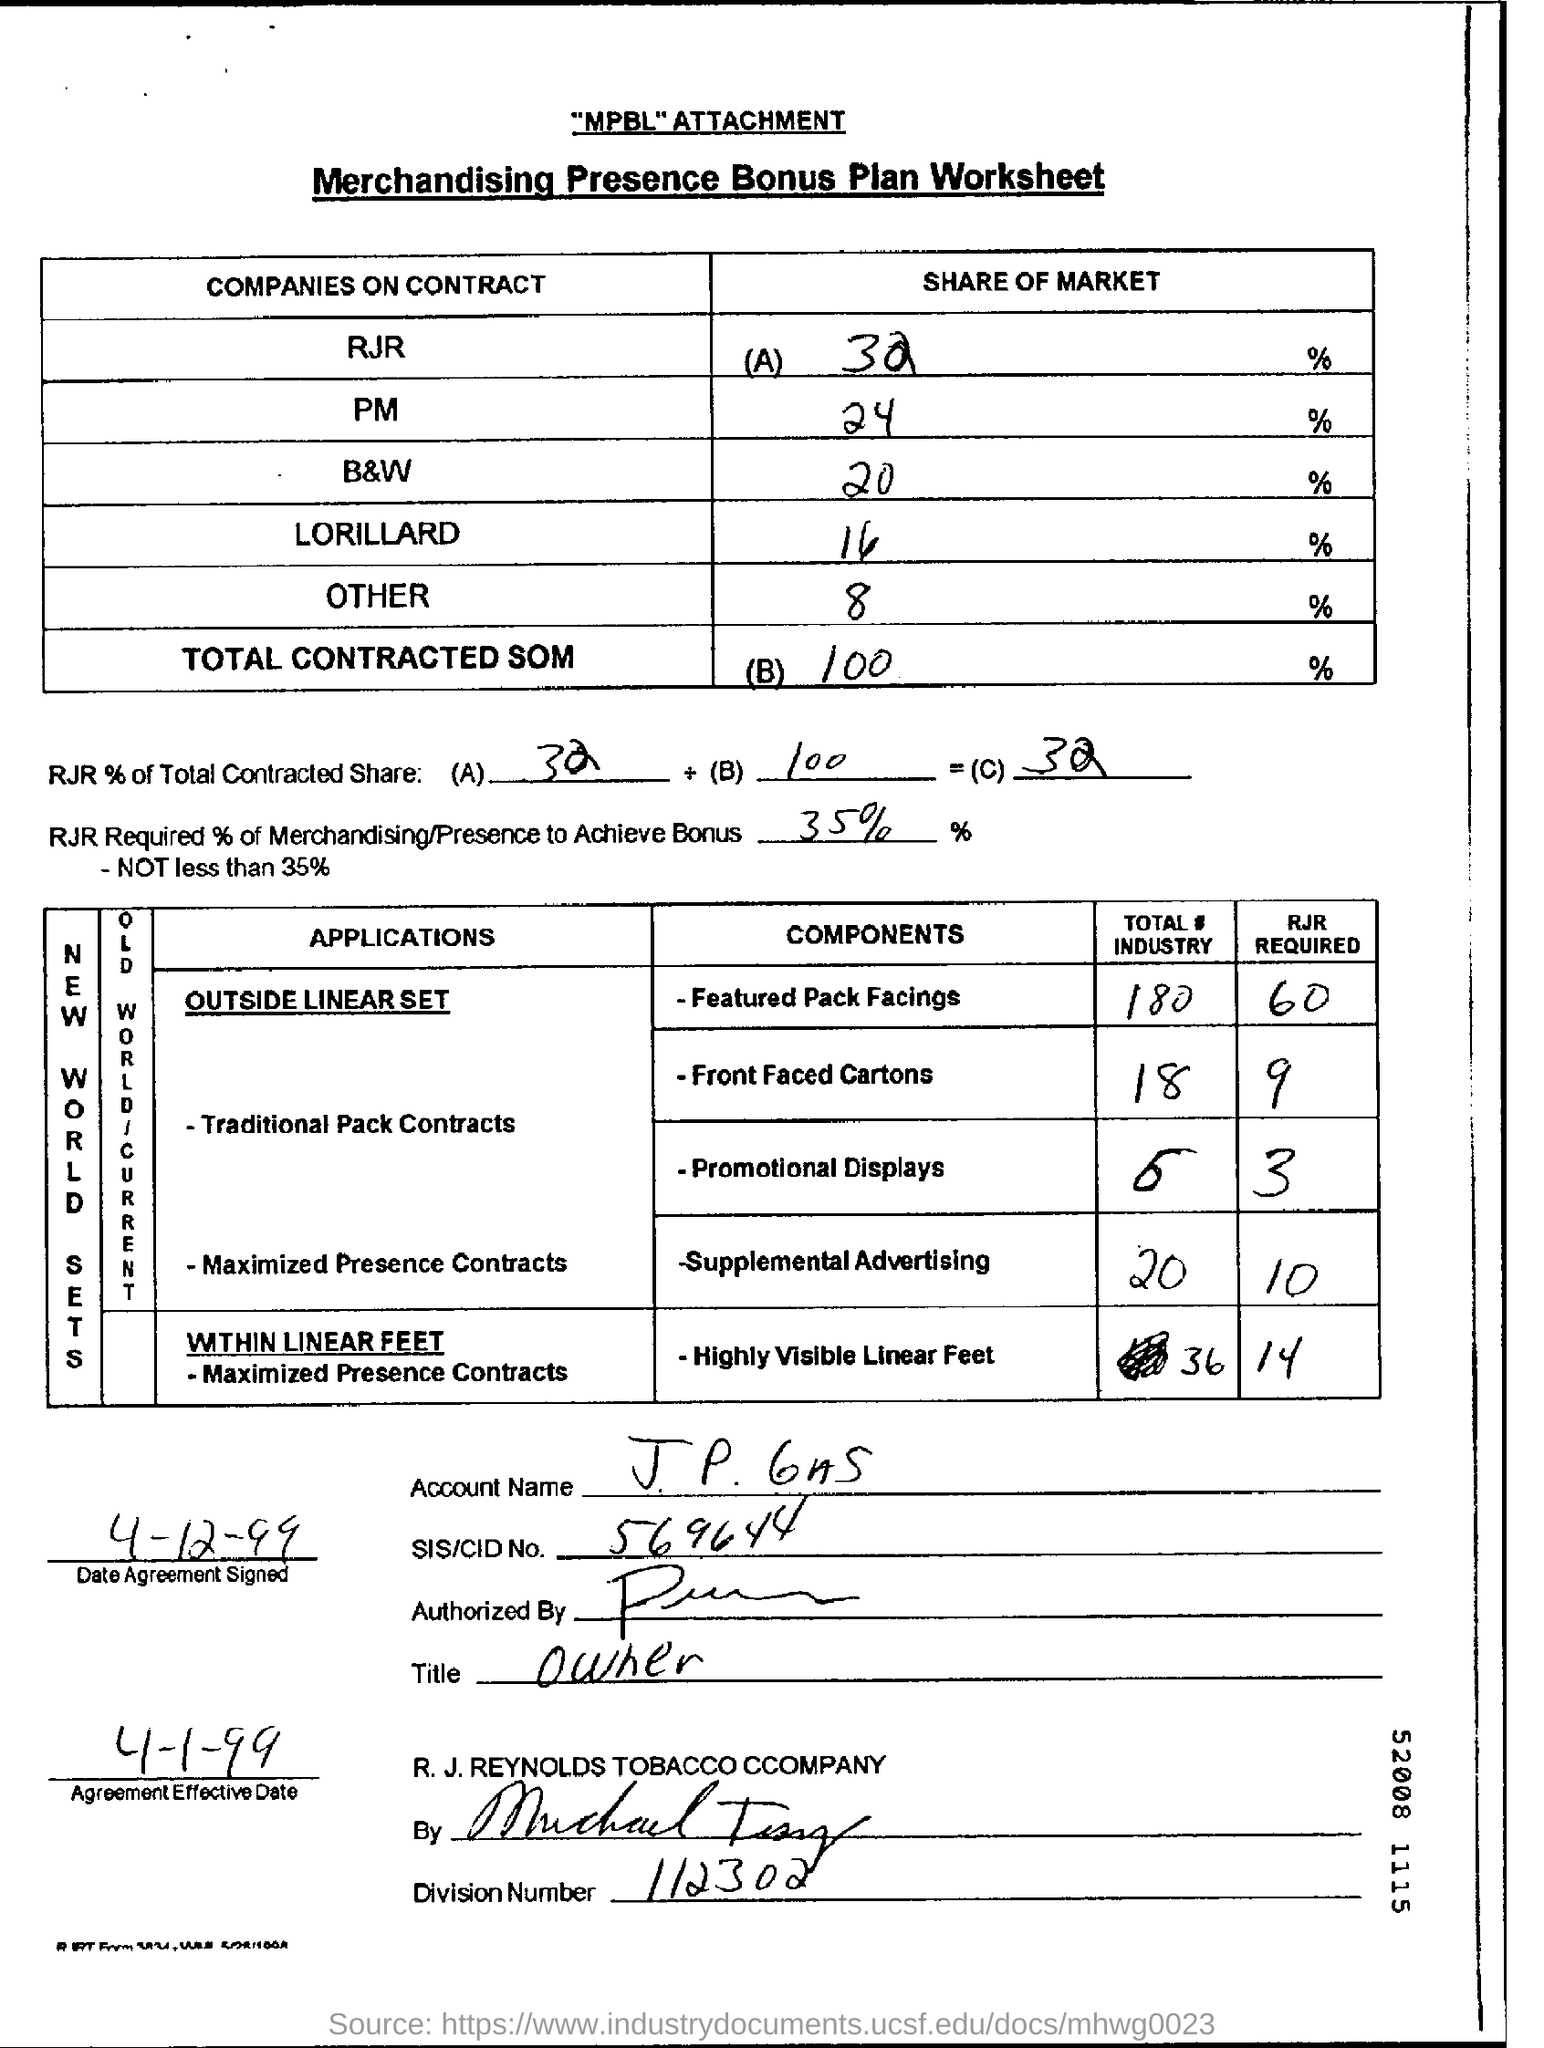Specify some key components in this picture. The division number is 112,302. The SIS/CID number is 569644... 